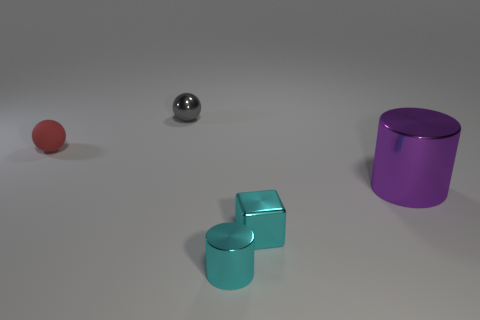The metallic cylinder that is the same color as the small cube is what size? small 